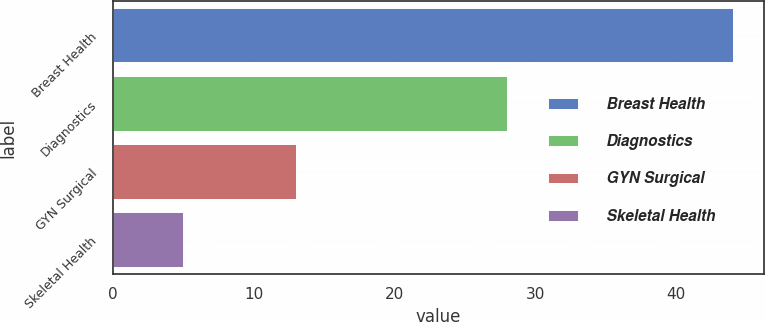<chart> <loc_0><loc_0><loc_500><loc_500><bar_chart><fcel>Breast Health<fcel>Diagnostics<fcel>GYN Surgical<fcel>Skeletal Health<nl><fcel>44<fcel>28<fcel>13<fcel>5<nl></chart> 